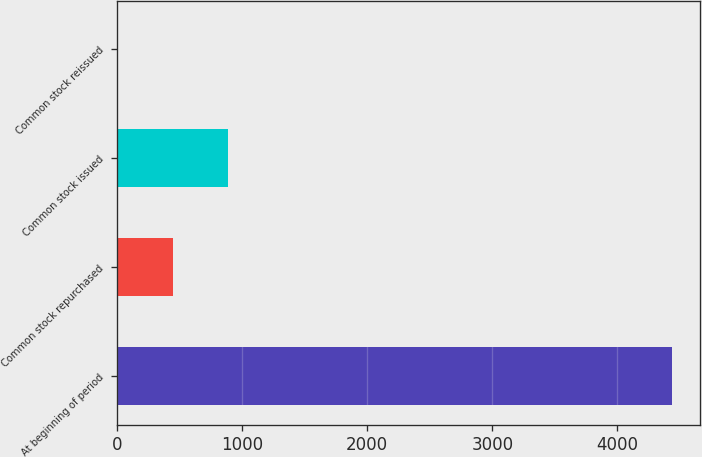Convert chart to OTSL. <chart><loc_0><loc_0><loc_500><loc_500><bar_chart><fcel>At beginning of period<fcel>Common stock repurchased<fcel>Common stock issued<fcel>Common stock reissued<nl><fcel>4436<fcel>444.5<fcel>888<fcel>1<nl></chart> 